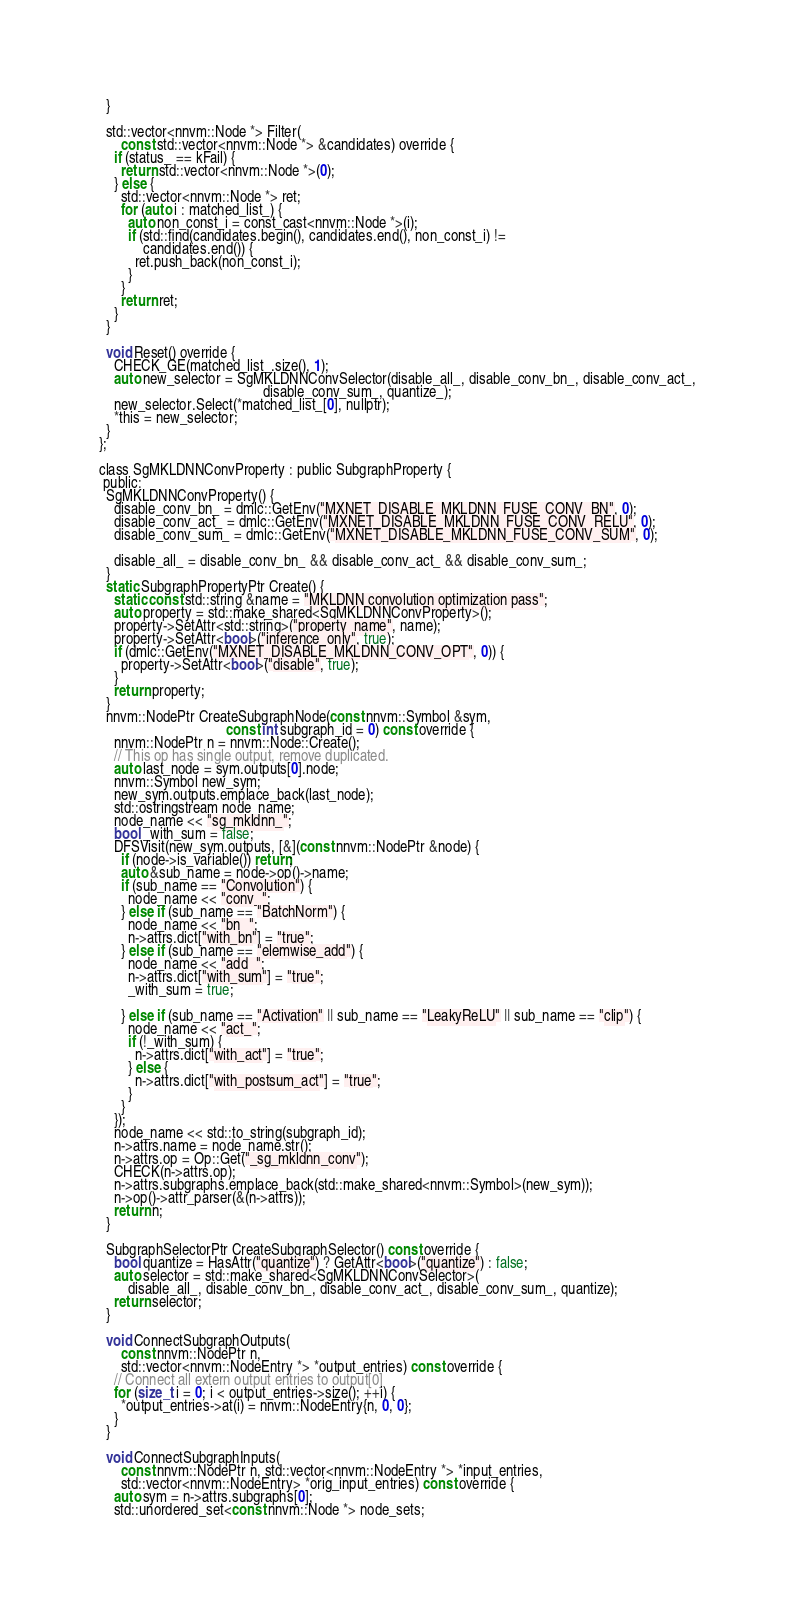Convert code to text. <code><loc_0><loc_0><loc_500><loc_500><_C_>  }

  std::vector<nnvm::Node *> Filter(
      const std::vector<nnvm::Node *> &candidates) override {
    if (status_ == kFail) {
      return std::vector<nnvm::Node *>(0);
    } else {
      std::vector<nnvm::Node *> ret;
      for (auto i : matched_list_) {
        auto non_const_i = const_cast<nnvm::Node *>(i);
        if (std::find(candidates.begin(), candidates.end(), non_const_i) !=
            candidates.end()) {
          ret.push_back(non_const_i);
        }
      }
      return ret;
    }
  }

  void Reset() override {
    CHECK_GE(matched_list_.size(), 1);
    auto new_selector = SgMKLDNNConvSelector(disable_all_, disable_conv_bn_, disable_conv_act_,
                                             disable_conv_sum_, quantize_);
    new_selector.Select(*matched_list_[0], nullptr);
    *this = new_selector;
  }
};

class SgMKLDNNConvProperty : public SubgraphProperty {
 public:
  SgMKLDNNConvProperty() {
    disable_conv_bn_ = dmlc::GetEnv("MXNET_DISABLE_MKLDNN_FUSE_CONV_BN", 0);
    disable_conv_act_ = dmlc::GetEnv("MXNET_DISABLE_MKLDNN_FUSE_CONV_RELU", 0);
    disable_conv_sum_ = dmlc::GetEnv("MXNET_DISABLE_MKLDNN_FUSE_CONV_SUM", 0);

    disable_all_ = disable_conv_bn_ && disable_conv_act_ && disable_conv_sum_;
  }
  static SubgraphPropertyPtr Create() {
    static const std::string &name = "MKLDNN convolution optimization pass";
    auto property = std::make_shared<SgMKLDNNConvProperty>();
    property->SetAttr<std::string>("property_name", name);
    property->SetAttr<bool>("inference_only", true);
    if (dmlc::GetEnv("MXNET_DISABLE_MKLDNN_CONV_OPT", 0)) {
      property->SetAttr<bool>("disable", true);
    }
    return property;
  }
  nnvm::NodePtr CreateSubgraphNode(const nnvm::Symbol &sym,
                                   const int subgraph_id = 0) const override {
    nnvm::NodePtr n = nnvm::Node::Create();
    // This op has single output, remove duplicated.
    auto last_node = sym.outputs[0].node;
    nnvm::Symbol new_sym;
    new_sym.outputs.emplace_back(last_node);
    std::ostringstream node_name;
    node_name << "sg_mkldnn_";
    bool _with_sum = false;
    DFSVisit(new_sym.outputs, [&](const nnvm::NodePtr &node) {
      if (node->is_variable()) return;
      auto &sub_name = node->op()->name;
      if (sub_name == "Convolution") {
        node_name << "conv_";
      } else if (sub_name == "BatchNorm") {
        node_name << "bn_";
        n->attrs.dict["with_bn"] = "true";
      } else if (sub_name == "elemwise_add") {
        node_name << "add_";
        n->attrs.dict["with_sum"] = "true";
        _with_sum = true;

      } else if (sub_name == "Activation" || sub_name == "LeakyReLU" || sub_name == "clip") {
        node_name << "act_";
        if (!_with_sum) {
          n->attrs.dict["with_act"] = "true";
        } else {
          n->attrs.dict["with_postsum_act"] = "true";
        }
      }
    });
    node_name << std::to_string(subgraph_id);
    n->attrs.name = node_name.str();
    n->attrs.op = Op::Get("_sg_mkldnn_conv");
    CHECK(n->attrs.op);
    n->attrs.subgraphs.emplace_back(std::make_shared<nnvm::Symbol>(new_sym));
    n->op()->attr_parser(&(n->attrs));
    return n;
  }

  SubgraphSelectorPtr CreateSubgraphSelector() const override {
    bool quantize = HasAttr("quantize") ? GetAttr<bool>("quantize") : false;
    auto selector = std::make_shared<SgMKLDNNConvSelector>(
        disable_all_, disable_conv_bn_, disable_conv_act_, disable_conv_sum_, quantize);
    return selector;
  }

  void ConnectSubgraphOutputs(
      const nnvm::NodePtr n,
      std::vector<nnvm::NodeEntry *> *output_entries) const override {
    // Connect all extern output entries to output[0]
    for (size_t i = 0; i < output_entries->size(); ++i) {
      *output_entries->at(i) = nnvm::NodeEntry{n, 0, 0};
    }
  }

  void ConnectSubgraphInputs(
      const nnvm::NodePtr n, std::vector<nnvm::NodeEntry *> *input_entries,
      std::vector<nnvm::NodeEntry> *orig_input_entries) const override {
    auto sym = n->attrs.subgraphs[0];
    std::unordered_set<const nnvm::Node *> node_sets;</code> 